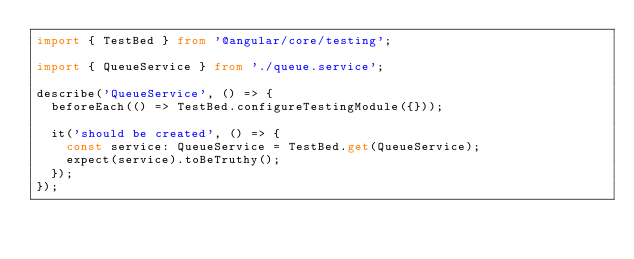Convert code to text. <code><loc_0><loc_0><loc_500><loc_500><_TypeScript_>import { TestBed } from '@angular/core/testing';

import { QueueService } from './queue.service';

describe('QueueService', () => {
  beforeEach(() => TestBed.configureTestingModule({}));

  it('should be created', () => {
    const service: QueueService = TestBed.get(QueueService);
    expect(service).toBeTruthy();
  });
});
</code> 